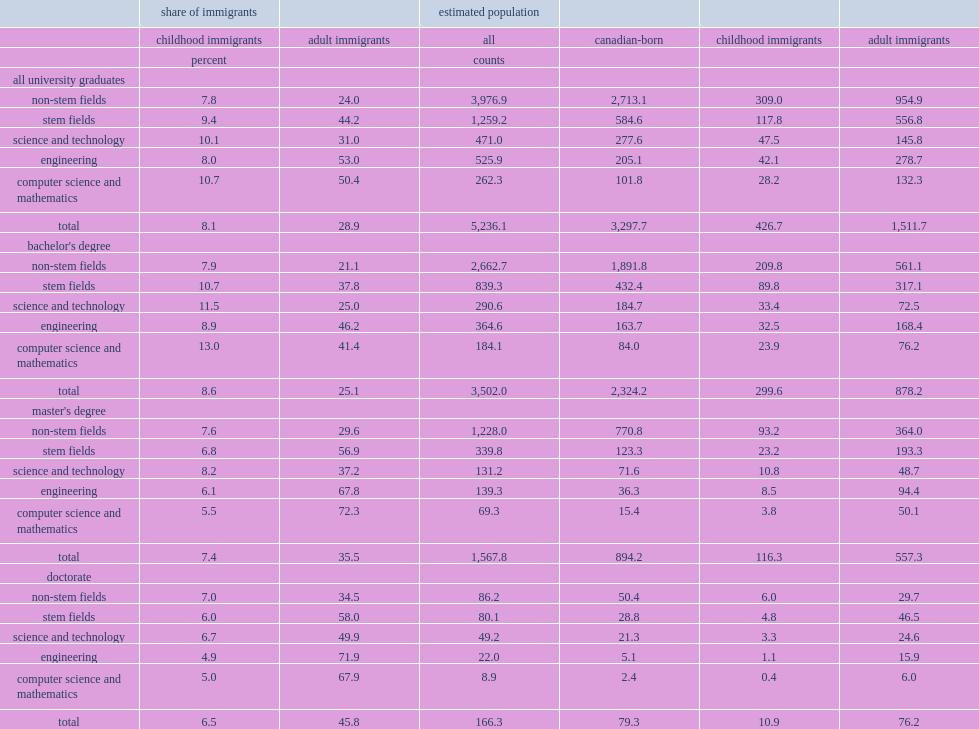Among engineering and computer science graduates aged 25 to 64 in 2016, how many percent of them were immigrants? 61.1. In 2016, what percent of the university-educated stem graduates in canada were immigrants. 53.6. What percent of bachelor's degree holders in stem fields were immigrants? 48.5. Among master's and doctoral stem graduates, what percent of them were immigrants? 64 63.7. 